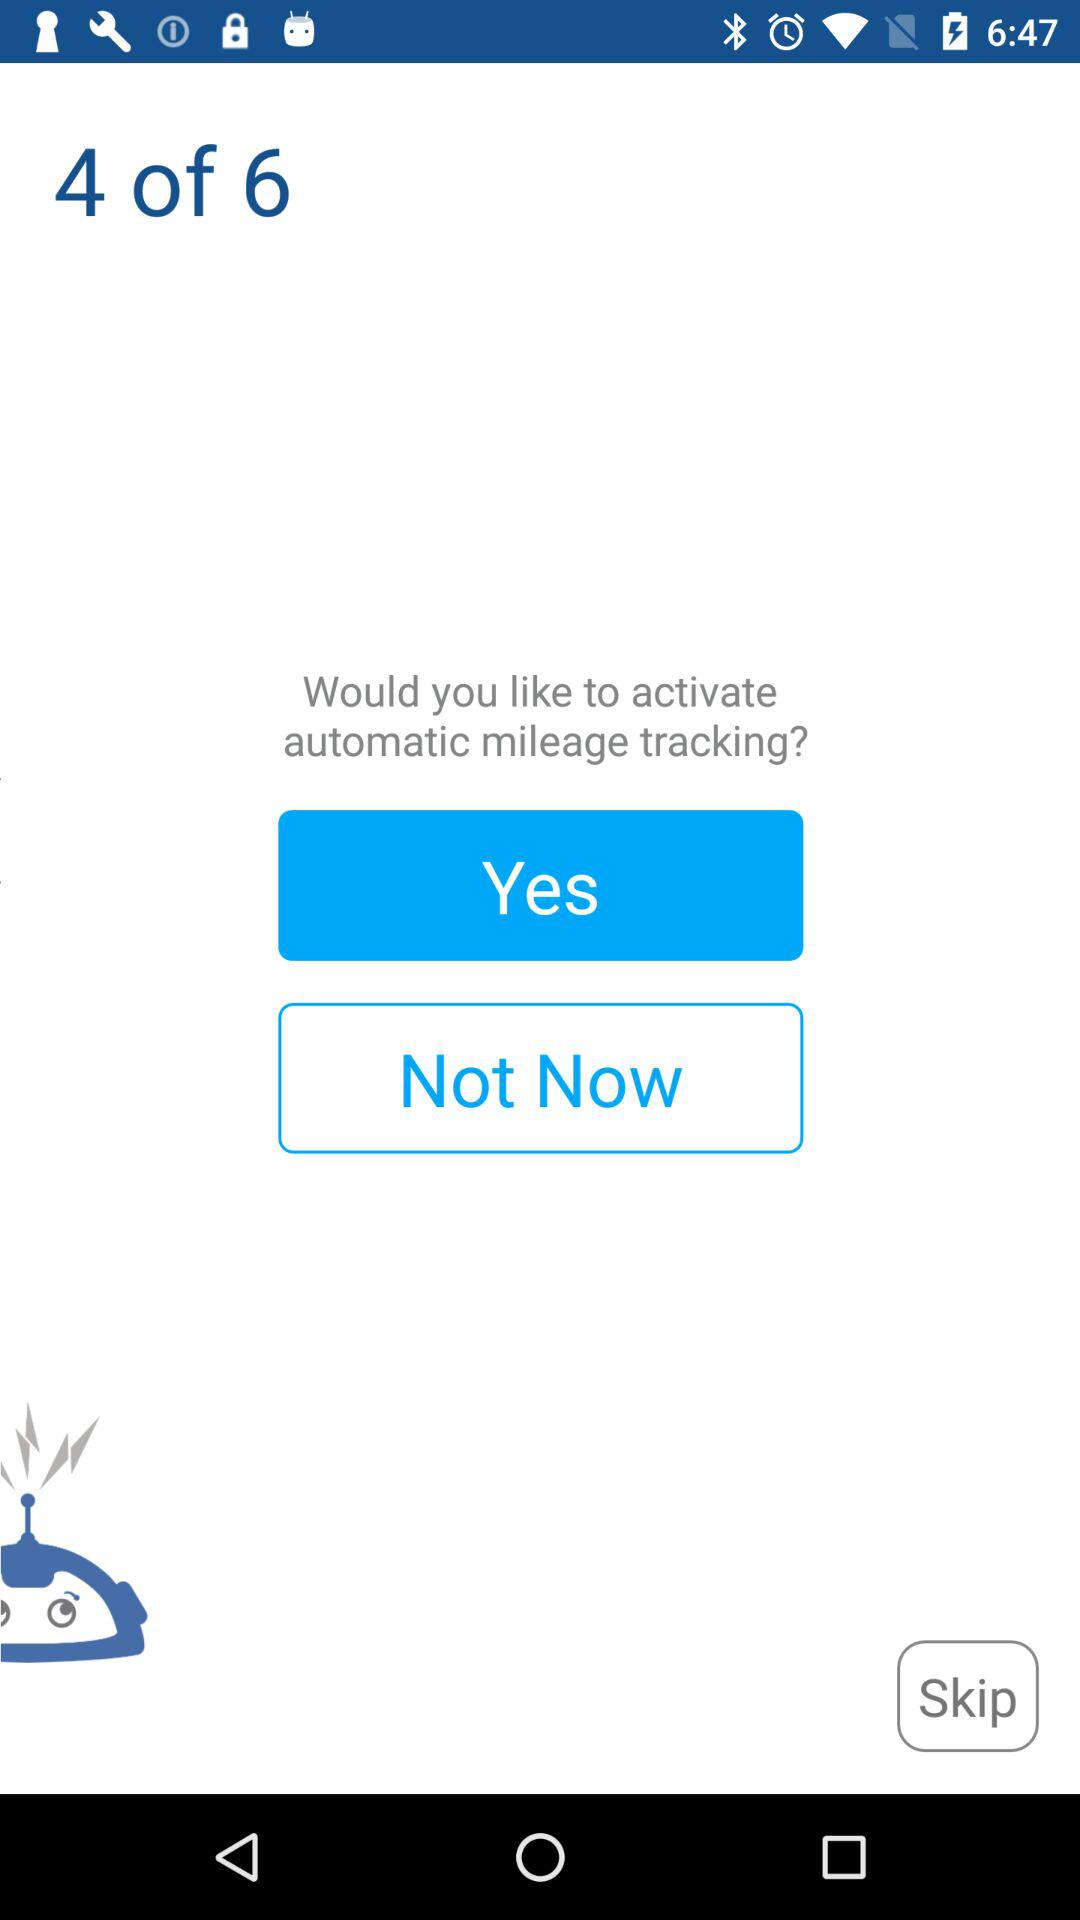How often is mileage tracked automatically?
When the provided information is insufficient, respond with <no answer>. <no answer> 